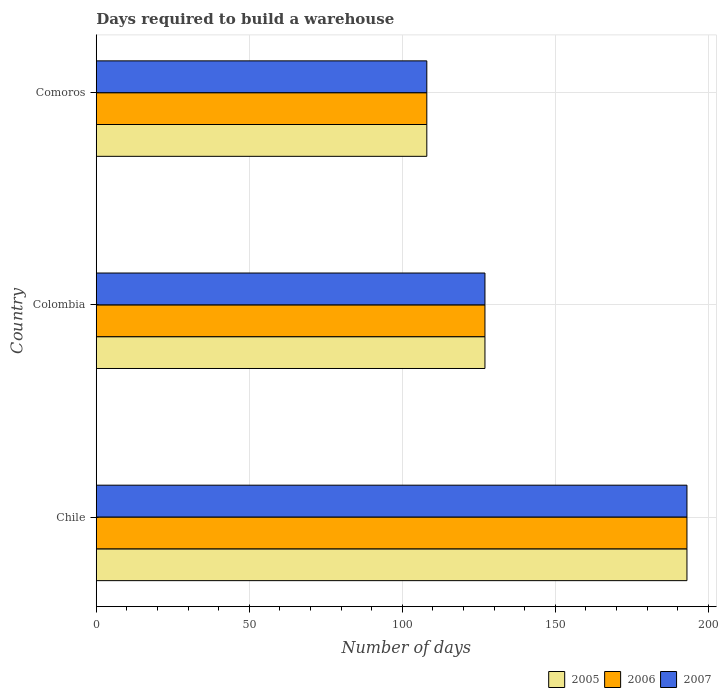How many different coloured bars are there?
Make the answer very short. 3. Are the number of bars per tick equal to the number of legend labels?
Provide a short and direct response. Yes. Are the number of bars on each tick of the Y-axis equal?
Provide a short and direct response. Yes. How many bars are there on the 1st tick from the bottom?
Ensure brevity in your answer.  3. What is the label of the 1st group of bars from the top?
Your response must be concise. Comoros. In how many cases, is the number of bars for a given country not equal to the number of legend labels?
Your answer should be very brief. 0. What is the days required to build a warehouse in in 2007 in Colombia?
Provide a short and direct response. 127. Across all countries, what is the maximum days required to build a warehouse in in 2007?
Ensure brevity in your answer.  193. Across all countries, what is the minimum days required to build a warehouse in in 2006?
Your answer should be compact. 108. In which country was the days required to build a warehouse in in 2006 maximum?
Provide a succinct answer. Chile. In which country was the days required to build a warehouse in in 2007 minimum?
Provide a succinct answer. Comoros. What is the total days required to build a warehouse in in 2006 in the graph?
Ensure brevity in your answer.  428. What is the difference between the days required to build a warehouse in in 2006 in Comoros and the days required to build a warehouse in in 2005 in Chile?
Your answer should be very brief. -85. What is the average days required to build a warehouse in in 2005 per country?
Keep it short and to the point. 142.67. What is the ratio of the days required to build a warehouse in in 2005 in Chile to that in Comoros?
Offer a terse response. 1.79. Is the days required to build a warehouse in in 2006 in Chile less than that in Comoros?
Provide a succinct answer. No. Is the difference between the days required to build a warehouse in in 2005 in Chile and Colombia greater than the difference between the days required to build a warehouse in in 2006 in Chile and Colombia?
Provide a short and direct response. No. What does the 1st bar from the bottom in Chile represents?
Your answer should be very brief. 2005. Is it the case that in every country, the sum of the days required to build a warehouse in in 2006 and days required to build a warehouse in in 2007 is greater than the days required to build a warehouse in in 2005?
Ensure brevity in your answer.  Yes. How many bars are there?
Keep it short and to the point. 9. What is the difference between two consecutive major ticks on the X-axis?
Keep it short and to the point. 50. How many legend labels are there?
Your answer should be very brief. 3. How are the legend labels stacked?
Offer a very short reply. Horizontal. What is the title of the graph?
Ensure brevity in your answer.  Days required to build a warehouse. Does "2005" appear as one of the legend labels in the graph?
Give a very brief answer. Yes. What is the label or title of the X-axis?
Offer a very short reply. Number of days. What is the label or title of the Y-axis?
Your answer should be compact. Country. What is the Number of days of 2005 in Chile?
Make the answer very short. 193. What is the Number of days of 2006 in Chile?
Your response must be concise. 193. What is the Number of days of 2007 in Chile?
Your answer should be very brief. 193. What is the Number of days of 2005 in Colombia?
Make the answer very short. 127. What is the Number of days in 2006 in Colombia?
Provide a short and direct response. 127. What is the Number of days of 2007 in Colombia?
Your answer should be compact. 127. What is the Number of days of 2005 in Comoros?
Provide a short and direct response. 108. What is the Number of days in 2006 in Comoros?
Provide a succinct answer. 108. What is the Number of days of 2007 in Comoros?
Offer a very short reply. 108. Across all countries, what is the maximum Number of days in 2005?
Offer a very short reply. 193. Across all countries, what is the maximum Number of days in 2006?
Offer a terse response. 193. Across all countries, what is the maximum Number of days in 2007?
Your answer should be compact. 193. Across all countries, what is the minimum Number of days in 2005?
Offer a terse response. 108. Across all countries, what is the minimum Number of days of 2006?
Offer a terse response. 108. Across all countries, what is the minimum Number of days of 2007?
Your response must be concise. 108. What is the total Number of days in 2005 in the graph?
Make the answer very short. 428. What is the total Number of days in 2006 in the graph?
Your answer should be compact. 428. What is the total Number of days in 2007 in the graph?
Your answer should be compact. 428. What is the difference between the Number of days of 2006 in Chile and that in Colombia?
Offer a terse response. 66. What is the difference between the Number of days in 2005 in Chile and that in Comoros?
Provide a short and direct response. 85. What is the difference between the Number of days of 2006 in Chile and that in Comoros?
Offer a terse response. 85. What is the difference between the Number of days of 2005 in Colombia and that in Comoros?
Your answer should be compact. 19. What is the difference between the Number of days of 2006 in Colombia and that in Comoros?
Make the answer very short. 19. What is the difference between the Number of days of 2007 in Colombia and that in Comoros?
Your answer should be very brief. 19. What is the difference between the Number of days in 2006 in Chile and the Number of days in 2007 in Colombia?
Provide a short and direct response. 66. What is the difference between the Number of days of 2006 in Chile and the Number of days of 2007 in Comoros?
Offer a terse response. 85. What is the difference between the Number of days of 2005 in Colombia and the Number of days of 2007 in Comoros?
Keep it short and to the point. 19. What is the difference between the Number of days in 2006 in Colombia and the Number of days in 2007 in Comoros?
Your answer should be compact. 19. What is the average Number of days of 2005 per country?
Your response must be concise. 142.67. What is the average Number of days of 2006 per country?
Your answer should be very brief. 142.67. What is the average Number of days of 2007 per country?
Make the answer very short. 142.67. What is the difference between the Number of days of 2005 and Number of days of 2006 in Colombia?
Offer a very short reply. 0. What is the difference between the Number of days of 2006 and Number of days of 2007 in Comoros?
Provide a succinct answer. 0. What is the ratio of the Number of days of 2005 in Chile to that in Colombia?
Provide a succinct answer. 1.52. What is the ratio of the Number of days in 2006 in Chile to that in Colombia?
Ensure brevity in your answer.  1.52. What is the ratio of the Number of days in 2007 in Chile to that in Colombia?
Give a very brief answer. 1.52. What is the ratio of the Number of days of 2005 in Chile to that in Comoros?
Offer a terse response. 1.79. What is the ratio of the Number of days of 2006 in Chile to that in Comoros?
Ensure brevity in your answer.  1.79. What is the ratio of the Number of days of 2007 in Chile to that in Comoros?
Offer a terse response. 1.79. What is the ratio of the Number of days in 2005 in Colombia to that in Comoros?
Keep it short and to the point. 1.18. What is the ratio of the Number of days in 2006 in Colombia to that in Comoros?
Your answer should be very brief. 1.18. What is the ratio of the Number of days of 2007 in Colombia to that in Comoros?
Your response must be concise. 1.18. What is the difference between the highest and the second highest Number of days in 2005?
Provide a succinct answer. 66. What is the difference between the highest and the second highest Number of days of 2006?
Offer a terse response. 66. What is the difference between the highest and the lowest Number of days of 2005?
Provide a succinct answer. 85. What is the difference between the highest and the lowest Number of days in 2006?
Your answer should be compact. 85. What is the difference between the highest and the lowest Number of days of 2007?
Provide a succinct answer. 85. 